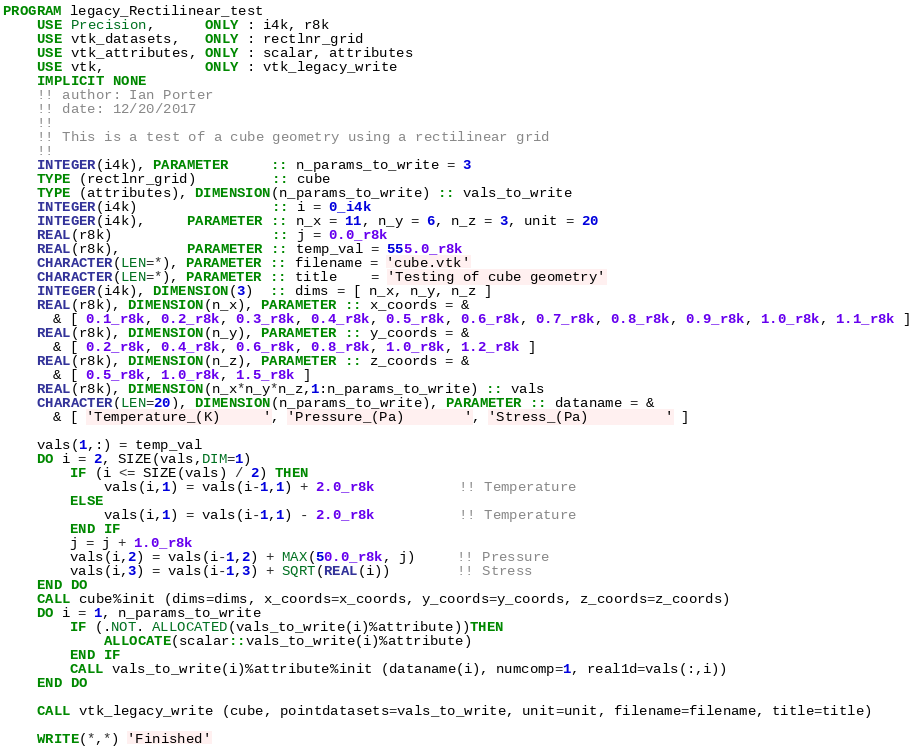Convert code to text. <code><loc_0><loc_0><loc_500><loc_500><_FORTRAN_>PROGRAM legacy_Rectilinear_test
    USE Precision,      ONLY : i4k, r8k
    USE vtk_datasets,   ONLY : rectlnr_grid
    USE vtk_attributes, ONLY : scalar, attributes
    USE vtk,            ONLY : vtk_legacy_write
    IMPLICIT NONE
    !! author: Ian Porter
    !! date: 12/20/2017
    !!
    !! This is a test of a cube geometry using a rectilinear grid
    !!
    INTEGER(i4k), PARAMETER     :: n_params_to_write = 3
    TYPE (rectlnr_grid)         :: cube
    TYPE (attributes), DIMENSION(n_params_to_write) :: vals_to_write
    INTEGER(i4k)                :: i = 0_i4k
    INTEGER(i4k),     PARAMETER :: n_x = 11, n_y = 6, n_z = 3, unit = 20
    REAL(r8k)                   :: j = 0.0_r8k
    REAL(r8k),        PARAMETER :: temp_val = 555.0_r8k
    CHARACTER(LEN=*), PARAMETER :: filename = 'cube.vtk'
    CHARACTER(LEN=*), PARAMETER :: title    = 'Testing of cube geometry'
    INTEGER(i4k), DIMENSION(3)  :: dims = [ n_x, n_y, n_z ]
    REAL(r8k), DIMENSION(n_x), PARAMETER :: x_coords = &
      & [ 0.1_r8k, 0.2_r8k, 0.3_r8k, 0.4_r8k, 0.5_r8k, 0.6_r8k, 0.7_r8k, 0.8_r8k, 0.9_r8k, 1.0_r8k, 1.1_r8k ]
    REAL(r8k), DIMENSION(n_y), PARAMETER :: y_coords = &
      & [ 0.2_r8k, 0.4_r8k, 0.6_r8k, 0.8_r8k, 1.0_r8k, 1.2_r8k ]
    REAL(r8k), DIMENSION(n_z), PARAMETER :: z_coords = &
      & [ 0.5_r8k, 1.0_r8k, 1.5_r8k ]
    REAL(r8k), DIMENSION(n_x*n_y*n_z,1:n_params_to_write) :: vals
    CHARACTER(LEN=20), DIMENSION(n_params_to_write), PARAMETER :: dataname = &
      & [ 'Temperature_(K)     ', 'Pressure_(Pa)       ', 'Stress_(Pa)         ' ]

    vals(1,:) = temp_val
    DO i = 2, SIZE(vals,DIM=1)
        IF (i <= SIZE(vals) / 2) THEN
            vals(i,1) = vals(i-1,1) + 2.0_r8k          !! Temperature
        ELSE
            vals(i,1) = vals(i-1,1) - 2.0_r8k          !! Temperature
        END IF
        j = j + 1.0_r8k
        vals(i,2) = vals(i-1,2) + MAX(50.0_r8k, j)     !! Pressure
        vals(i,3) = vals(i-1,3) + SQRT(REAL(i))        !! Stress
    END DO
    CALL cube%init (dims=dims, x_coords=x_coords, y_coords=y_coords, z_coords=z_coords)
    DO i = 1, n_params_to_write
        IF (.NOT. ALLOCATED(vals_to_write(i)%attribute))THEN
            ALLOCATE(scalar::vals_to_write(i)%attribute)
        END IF
        CALL vals_to_write(i)%attribute%init (dataname(i), numcomp=1, real1d=vals(:,i))
    END DO

    CALL vtk_legacy_write (cube, pointdatasets=vals_to_write, unit=unit, filename=filename, title=title)

    WRITE(*,*) 'Finished'
</code> 